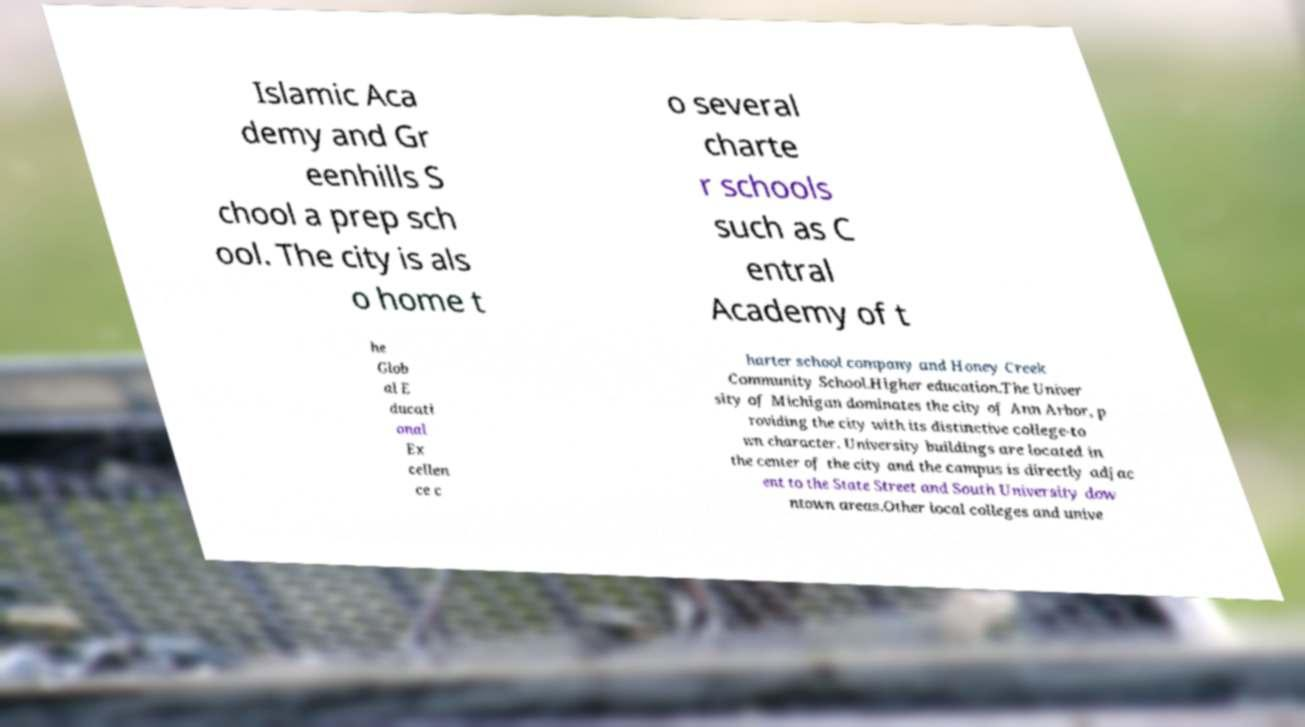For documentation purposes, I need the text within this image transcribed. Could you provide that? Islamic Aca demy and Gr eenhills S chool a prep sch ool. The city is als o home t o several charte r schools such as C entral Academy of t he Glob al E ducati onal Ex cellen ce c harter school company and Honey Creek Community School.Higher education.The Univer sity of Michigan dominates the city of Ann Arbor, p roviding the city with its distinctive college-to wn character. University buildings are located in the center of the city and the campus is directly adjac ent to the State Street and South University dow ntown areas.Other local colleges and unive 